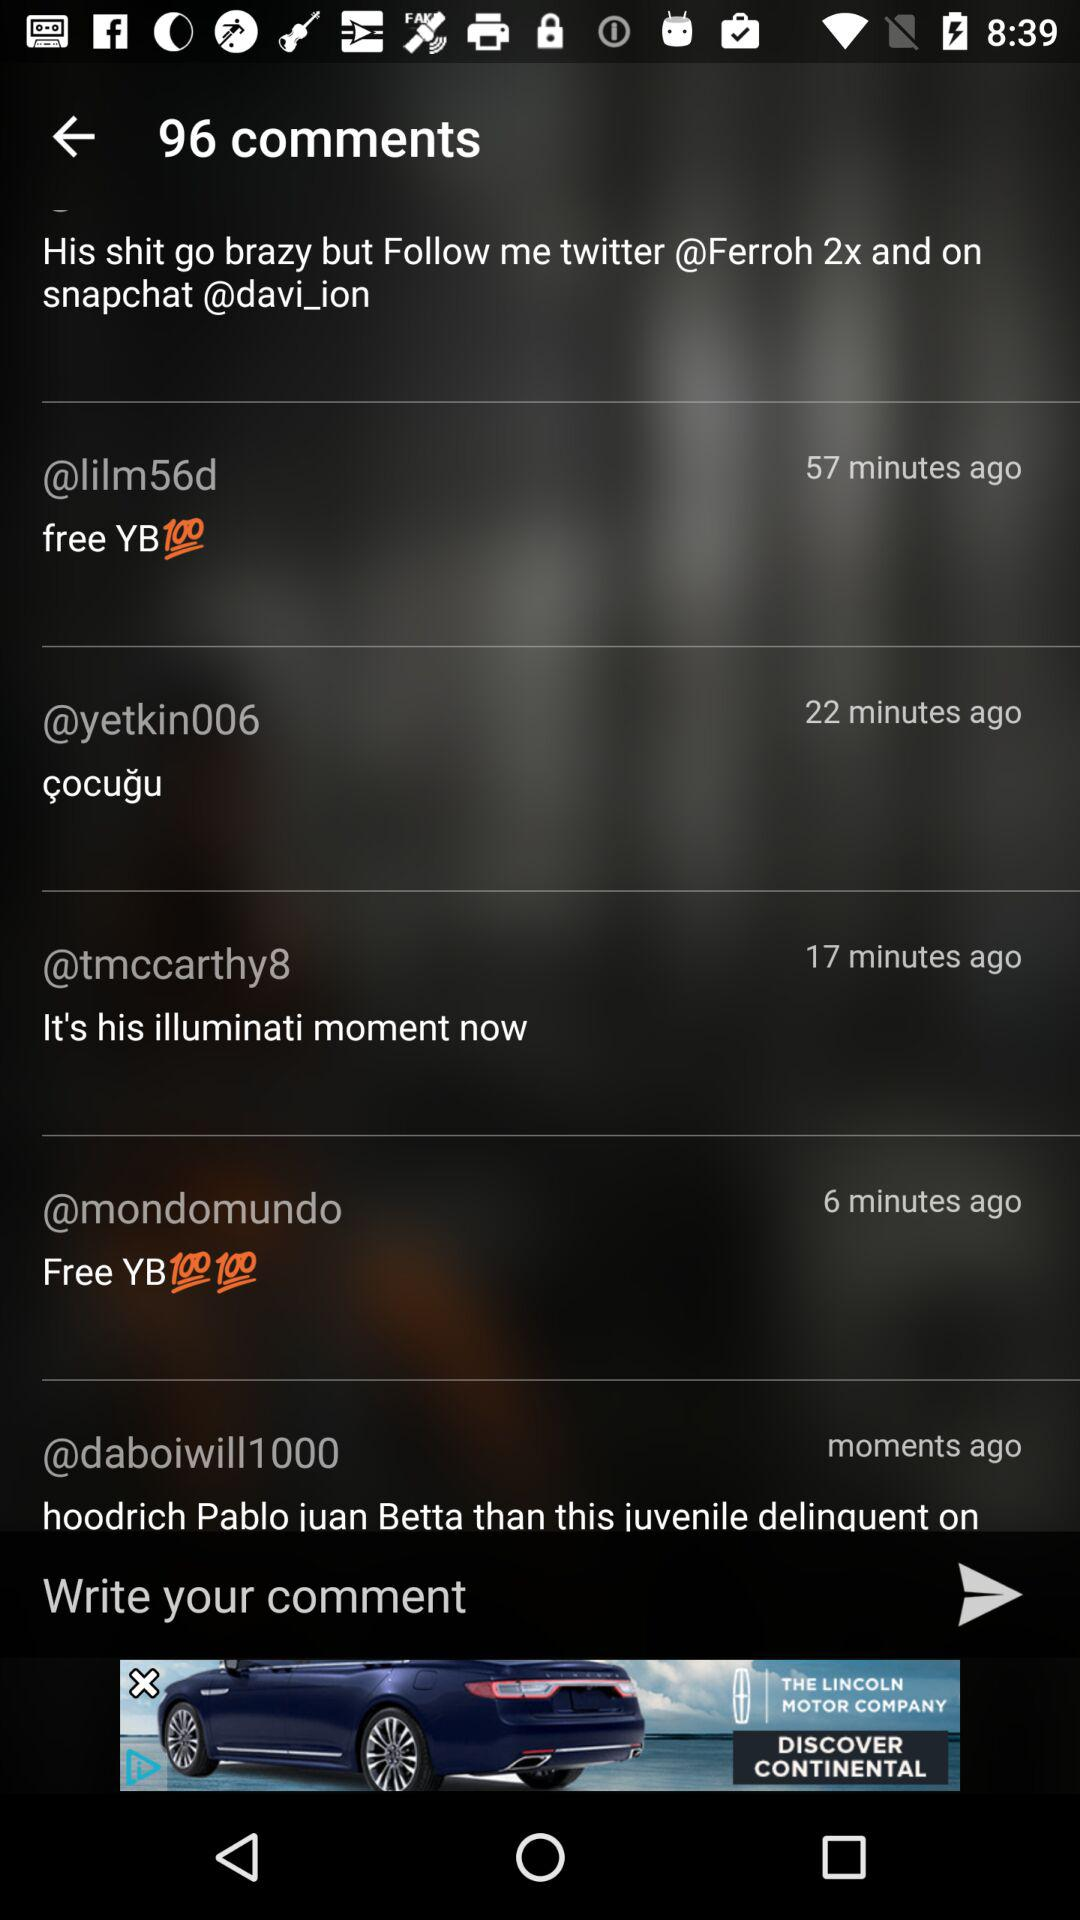When did tmccarthy comment? The tmccarthy did a comment 17 minutes ago. 